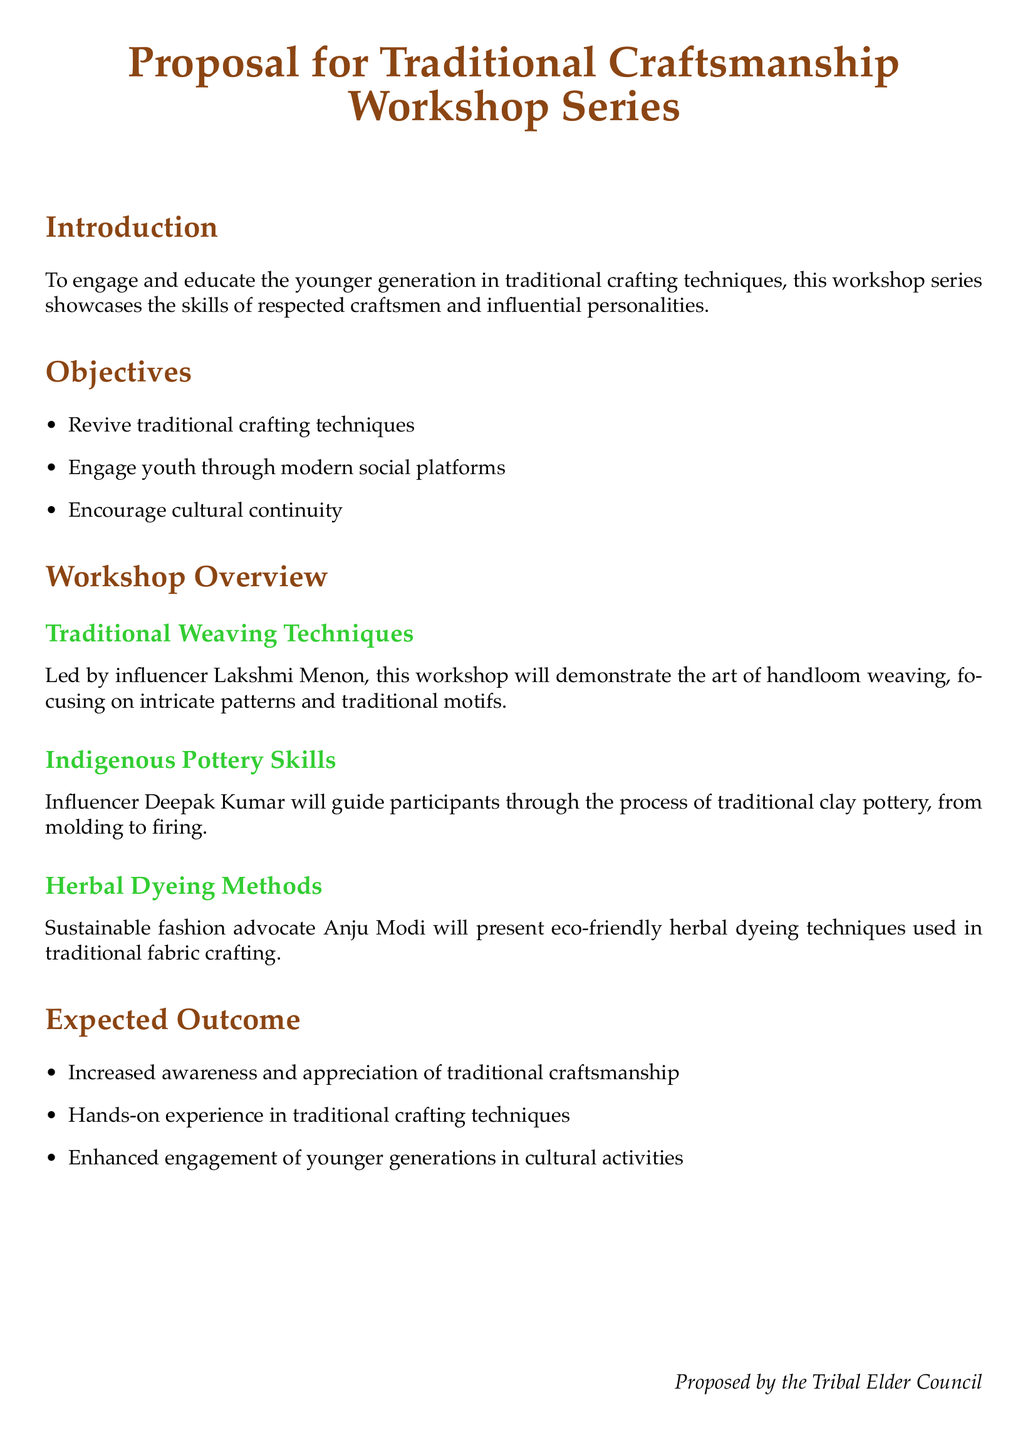What is the title of the proposal? The title of the proposal is stated at the beginning of the document.
Answer: Proposal for Traditional Craftsmanship Workshop Series Who is the influencer leading the weaving workshop? The document specifies the influencer for each workshop.
Answer: Lakshmi Menon What are the three main objectives of the proposal? The proposal lists three objectives in bullet points under the objectives section.
Answer: Revive traditional crafting techniques, Engage youth through modern social platforms, Encourage cultural continuity What traditional skill will Deepak Kumar teach? The document mentions the specific skill that Deepak Kumar will guide participants in.
Answer: Indigenous Pottery Skills What is one expected outcome of the workshop series? The proposal outlines expected outcomes in a bullet point list.
Answer: Increased awareness and appreciation of traditional craftsmanship How many workshops are mentioned in the overview section? By counting the different workshops listed in the overview section of the document.
Answer: Three Who is the sustainable fashion advocate featured in the workshops? The document identifies the influencer focused on herbal dyeing techniques.
Answer: Anju Modi What type of document is this? The main purpose of the content can be inferred from the title and structure.
Answer: Proposal What is the concluding phrase of the document? The document ends with a specific closing phrase from the proposing body.
Answer: Proposed by the Tribal Elder Council 